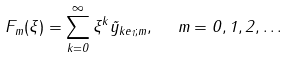Convert formula to latex. <formula><loc_0><loc_0><loc_500><loc_500>F _ { m } ( \xi ) = \sum _ { k = 0 } ^ { \infty } \xi ^ { k } \tilde { y } _ { k e _ { 1 } ; m } , \ \ m = 0 , 1 , 2 , \dots</formula> 